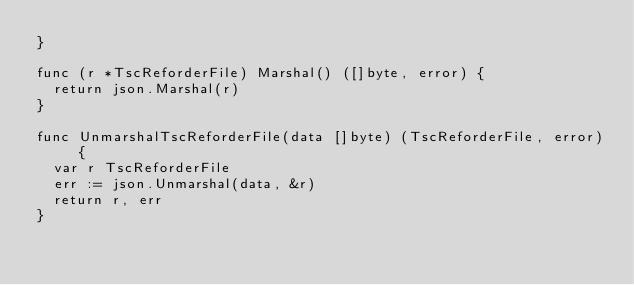<code> <loc_0><loc_0><loc_500><loc_500><_Go_>}

func (r *TscReforderFile) Marshal() ([]byte, error) {
	return json.Marshal(r)
}

func UnmarshalTscReforderFile(data []byte) (TscReforderFile, error) {
	var r TscReforderFile
	err := json.Unmarshal(data, &r)
	return r, err
}
</code> 